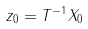Convert formula to latex. <formula><loc_0><loc_0><loc_500><loc_500>z _ { 0 } = T ^ { - 1 } X _ { 0 }</formula> 